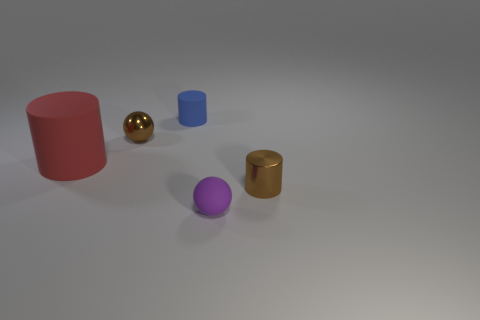Which objects in the image have a metallic texture? The sphere and the small cylinder on the right both have metallic textures. The sphere has a gold finish, whereas the cylinder appears to have a brushed gold surface. 